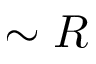<formula> <loc_0><loc_0><loc_500><loc_500>\sim R</formula> 